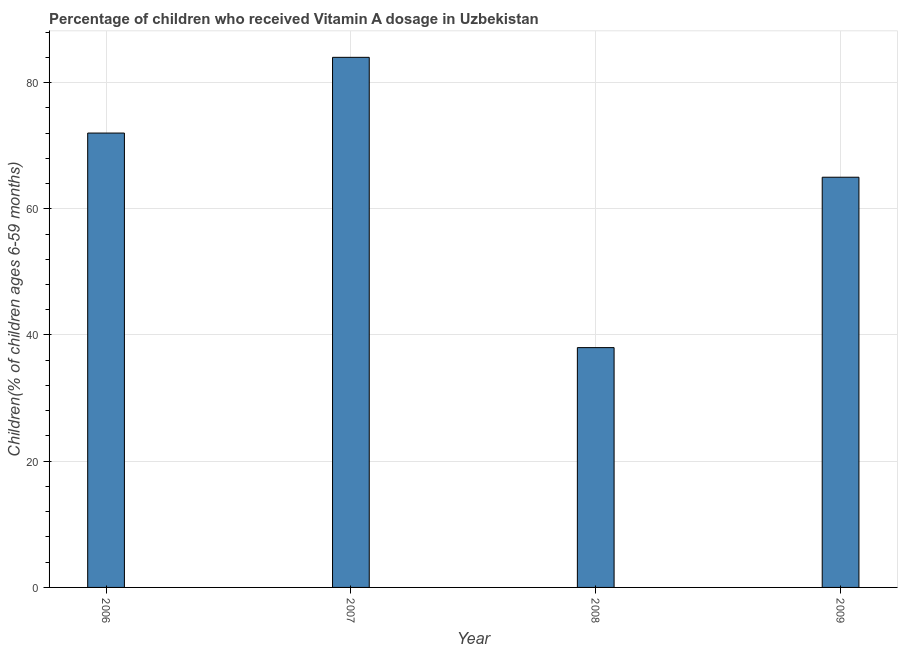What is the title of the graph?
Give a very brief answer. Percentage of children who received Vitamin A dosage in Uzbekistan. What is the label or title of the X-axis?
Provide a succinct answer. Year. What is the label or title of the Y-axis?
Your response must be concise. Children(% of children ages 6-59 months). What is the vitamin a supplementation coverage rate in 2007?
Give a very brief answer. 84. Across all years, what is the minimum vitamin a supplementation coverage rate?
Your answer should be very brief. 38. In which year was the vitamin a supplementation coverage rate maximum?
Keep it short and to the point. 2007. In which year was the vitamin a supplementation coverage rate minimum?
Provide a short and direct response. 2008. What is the sum of the vitamin a supplementation coverage rate?
Provide a succinct answer. 259. What is the difference between the vitamin a supplementation coverage rate in 2007 and 2008?
Ensure brevity in your answer.  46. What is the average vitamin a supplementation coverage rate per year?
Make the answer very short. 64.75. What is the median vitamin a supplementation coverage rate?
Offer a terse response. 68.5. Do a majority of the years between 2009 and 2006 (inclusive) have vitamin a supplementation coverage rate greater than 44 %?
Provide a short and direct response. Yes. What is the ratio of the vitamin a supplementation coverage rate in 2006 to that in 2009?
Offer a terse response. 1.11. What is the difference between the highest and the lowest vitamin a supplementation coverage rate?
Keep it short and to the point. 46. In how many years, is the vitamin a supplementation coverage rate greater than the average vitamin a supplementation coverage rate taken over all years?
Make the answer very short. 3. How many years are there in the graph?
Give a very brief answer. 4. Are the values on the major ticks of Y-axis written in scientific E-notation?
Keep it short and to the point. No. What is the Children(% of children ages 6-59 months) in 2008?
Make the answer very short. 38. What is the difference between the Children(% of children ages 6-59 months) in 2007 and 2008?
Give a very brief answer. 46. What is the difference between the Children(% of children ages 6-59 months) in 2008 and 2009?
Give a very brief answer. -27. What is the ratio of the Children(% of children ages 6-59 months) in 2006 to that in 2007?
Offer a terse response. 0.86. What is the ratio of the Children(% of children ages 6-59 months) in 2006 to that in 2008?
Provide a succinct answer. 1.9. What is the ratio of the Children(% of children ages 6-59 months) in 2006 to that in 2009?
Provide a succinct answer. 1.11. What is the ratio of the Children(% of children ages 6-59 months) in 2007 to that in 2008?
Provide a succinct answer. 2.21. What is the ratio of the Children(% of children ages 6-59 months) in 2007 to that in 2009?
Your response must be concise. 1.29. What is the ratio of the Children(% of children ages 6-59 months) in 2008 to that in 2009?
Provide a succinct answer. 0.58. 